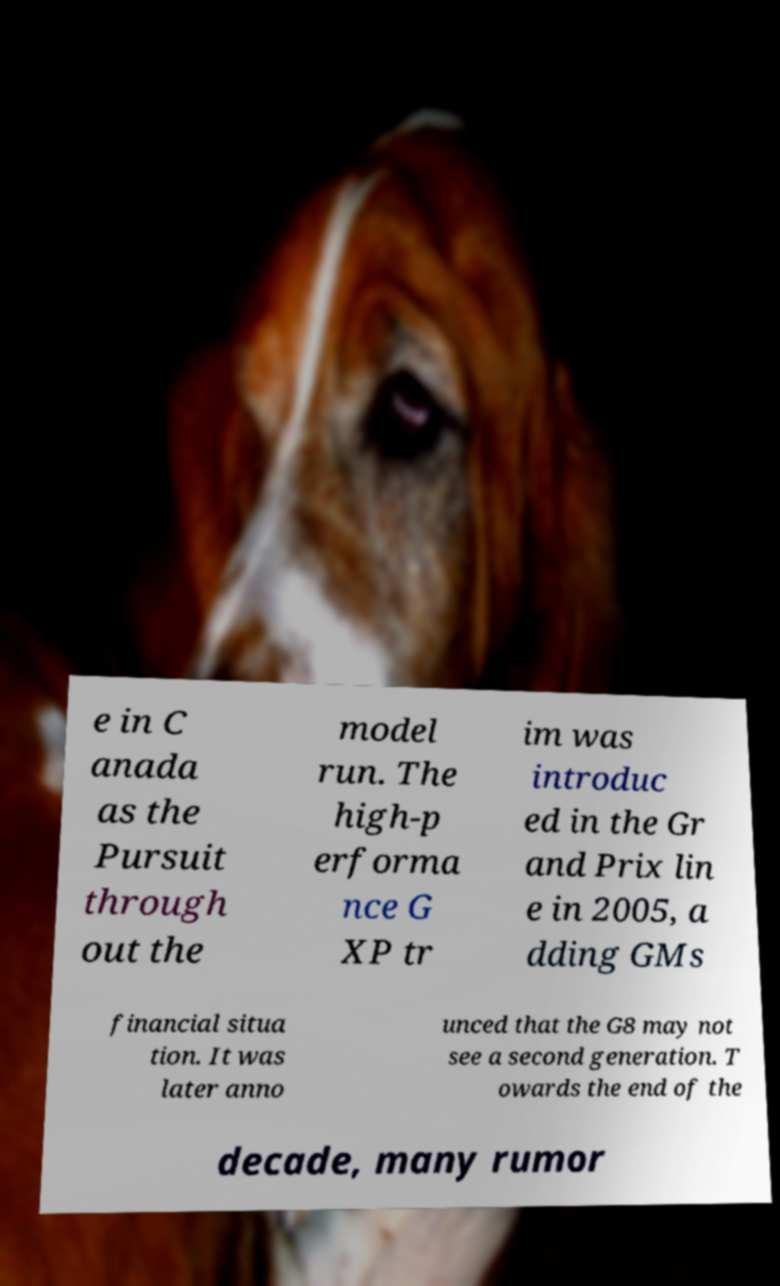Can you read and provide the text displayed in the image?This photo seems to have some interesting text. Can you extract and type it out for me? e in C anada as the Pursuit through out the model run. The high-p erforma nce G XP tr im was introduc ed in the Gr and Prix lin e in 2005, a dding GMs financial situa tion. It was later anno unced that the G8 may not see a second generation. T owards the end of the decade, many rumor 